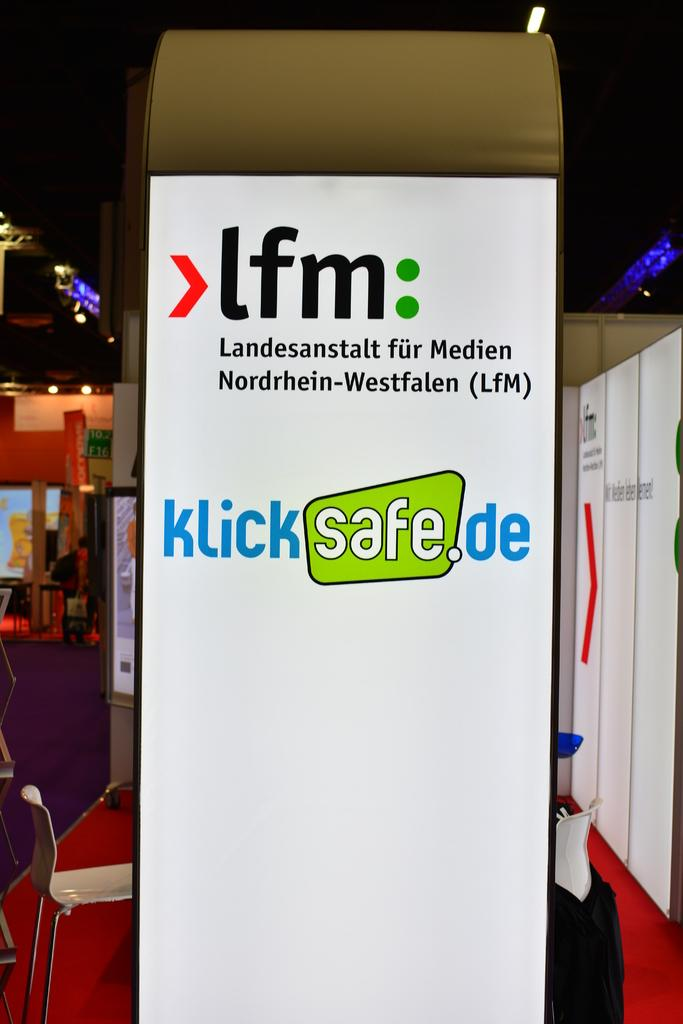<image>
Create a compact narrative representing the image presented. A display stand at a conference is in German and is an advert for klicksafe.de 